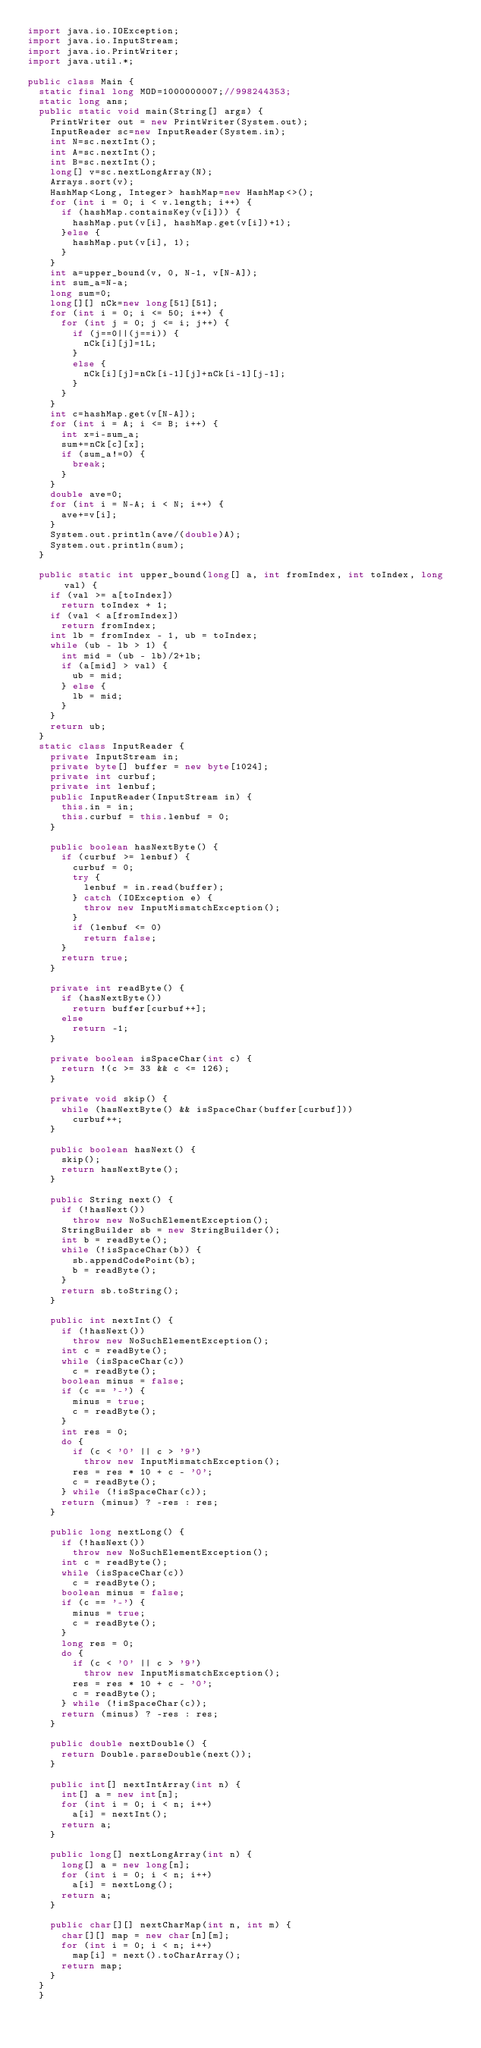Convert code to text. <code><loc_0><loc_0><loc_500><loc_500><_Java_>import java.io.IOException;
import java.io.InputStream;
import java.io.PrintWriter;
import java.util.*;

public class Main {
	static final long MOD=1000000007;//998244353;
	static long ans;
	public static void main(String[] args) {
		PrintWriter out = new PrintWriter(System.out);
		InputReader sc=new InputReader(System.in);
		int N=sc.nextInt();
		int A=sc.nextInt();
		int B=sc.nextInt();
		long[] v=sc.nextLongArray(N);
		Arrays.sort(v);
		HashMap<Long, Integer> hashMap=new HashMap<>();
		for (int i = 0; i < v.length; i++) {
			if (hashMap.containsKey(v[i])) {
				hashMap.put(v[i], hashMap.get(v[i])+1);
			}else {
				hashMap.put(v[i], 1);
			}
		}
		int a=upper_bound(v, 0, N-1, v[N-A]);
		int sum_a=N-a;
		long sum=0;
		long[][] nCk=new long[51][51];
		for (int i = 0; i <= 50; i++) {
			for (int j = 0; j <= i; j++) {
				if (j==0||(j==i)) {
					nCk[i][j]=1L;
				}
				else {
					nCk[i][j]=nCk[i-1][j]+nCk[i-1][j-1];
				}
			}
		}
		int c=hashMap.get(v[N-A]);
		for (int i = A; i <= B; i++) {
			int x=i-sum_a;
			sum+=nCk[c][x];
			if (sum_a!=0) {
				break;
			}
		}
		double ave=0;
		for (int i = N-A; i < N; i++) {
			ave+=v[i];
		}
		System.out.println(ave/(double)A);
		System.out.println(sum);
 	}
	
	public static int upper_bound(long[] a, int fromIndex, int toIndex, long val) {
		if (val >= a[toIndex])
			return toIndex + 1;
		if (val < a[fromIndex])
			return fromIndex;
		int lb = fromIndex - 1, ub = toIndex;
		while (ub - lb > 1) {
			int mid = (ub - lb)/2+lb;
			if (a[mid] > val) {
				ub = mid;
			} else {
				lb = mid;
			}
		}
		return ub;
	}
	static class InputReader { 
		private InputStream in;
		private byte[] buffer = new byte[1024];
		private int curbuf;
		private int lenbuf;
		public InputReader(InputStream in) {
			this.in = in;
			this.curbuf = this.lenbuf = 0;
		}
 
		public boolean hasNextByte() {
			if (curbuf >= lenbuf) {
				curbuf = 0;
				try {
					lenbuf = in.read(buffer);
				} catch (IOException e) {
					throw new InputMismatchException();
				}
				if (lenbuf <= 0)
					return false;
			}
			return true;
		}
 
		private int readByte() {
			if (hasNextByte())
				return buffer[curbuf++];
			else
				return -1;
		}
 
		private boolean isSpaceChar(int c) {
			return !(c >= 33 && c <= 126);
		}
 
		private void skip() {
			while (hasNextByte() && isSpaceChar(buffer[curbuf]))
				curbuf++;
		}
 
		public boolean hasNext() {
			skip();
			return hasNextByte();
		}
 
		public String next() {
			if (!hasNext())
				throw new NoSuchElementException();
			StringBuilder sb = new StringBuilder();
			int b = readByte();
			while (!isSpaceChar(b)) {
				sb.appendCodePoint(b);
				b = readByte();
			}
			return sb.toString();
		}
 
		public int nextInt() {
			if (!hasNext())
				throw new NoSuchElementException();
			int c = readByte();
			while (isSpaceChar(c))
				c = readByte();
			boolean minus = false;
			if (c == '-') {
				minus = true;
				c = readByte();
			}
			int res = 0;
			do {
				if (c < '0' || c > '9')
					throw new InputMismatchException();
				res = res * 10 + c - '0';
				c = readByte();
			} while (!isSpaceChar(c));
			return (minus) ? -res : res;
		}
 
		public long nextLong() {
			if (!hasNext())
				throw new NoSuchElementException();
			int c = readByte();
			while (isSpaceChar(c))
				c = readByte();
			boolean minus = false;
			if (c == '-') {
				minus = true;
				c = readByte();
			}
			long res = 0;
			do {
				if (c < '0' || c > '9')
					throw new InputMismatchException();
				res = res * 10 + c - '0';
				c = readByte();
			} while (!isSpaceChar(c));
			return (minus) ? -res : res;
		}
 
		public double nextDouble() {
			return Double.parseDouble(next());
		}
 
		public int[] nextIntArray(int n) {
			int[] a = new int[n];
			for (int i = 0; i < n; i++)
				a[i] = nextInt();
			return a;
		}
 
		public long[] nextLongArray(int n) {
			long[] a = new long[n];
			for (int i = 0; i < n; i++)
				a[i] = nextLong();
			return a;
		}
 
		public char[][] nextCharMap(int n, int m) {
			char[][] map = new char[n][m];
			for (int i = 0; i < n; i++)
				map[i] = next().toCharArray();
			return map;
		}
	}
	}
</code> 